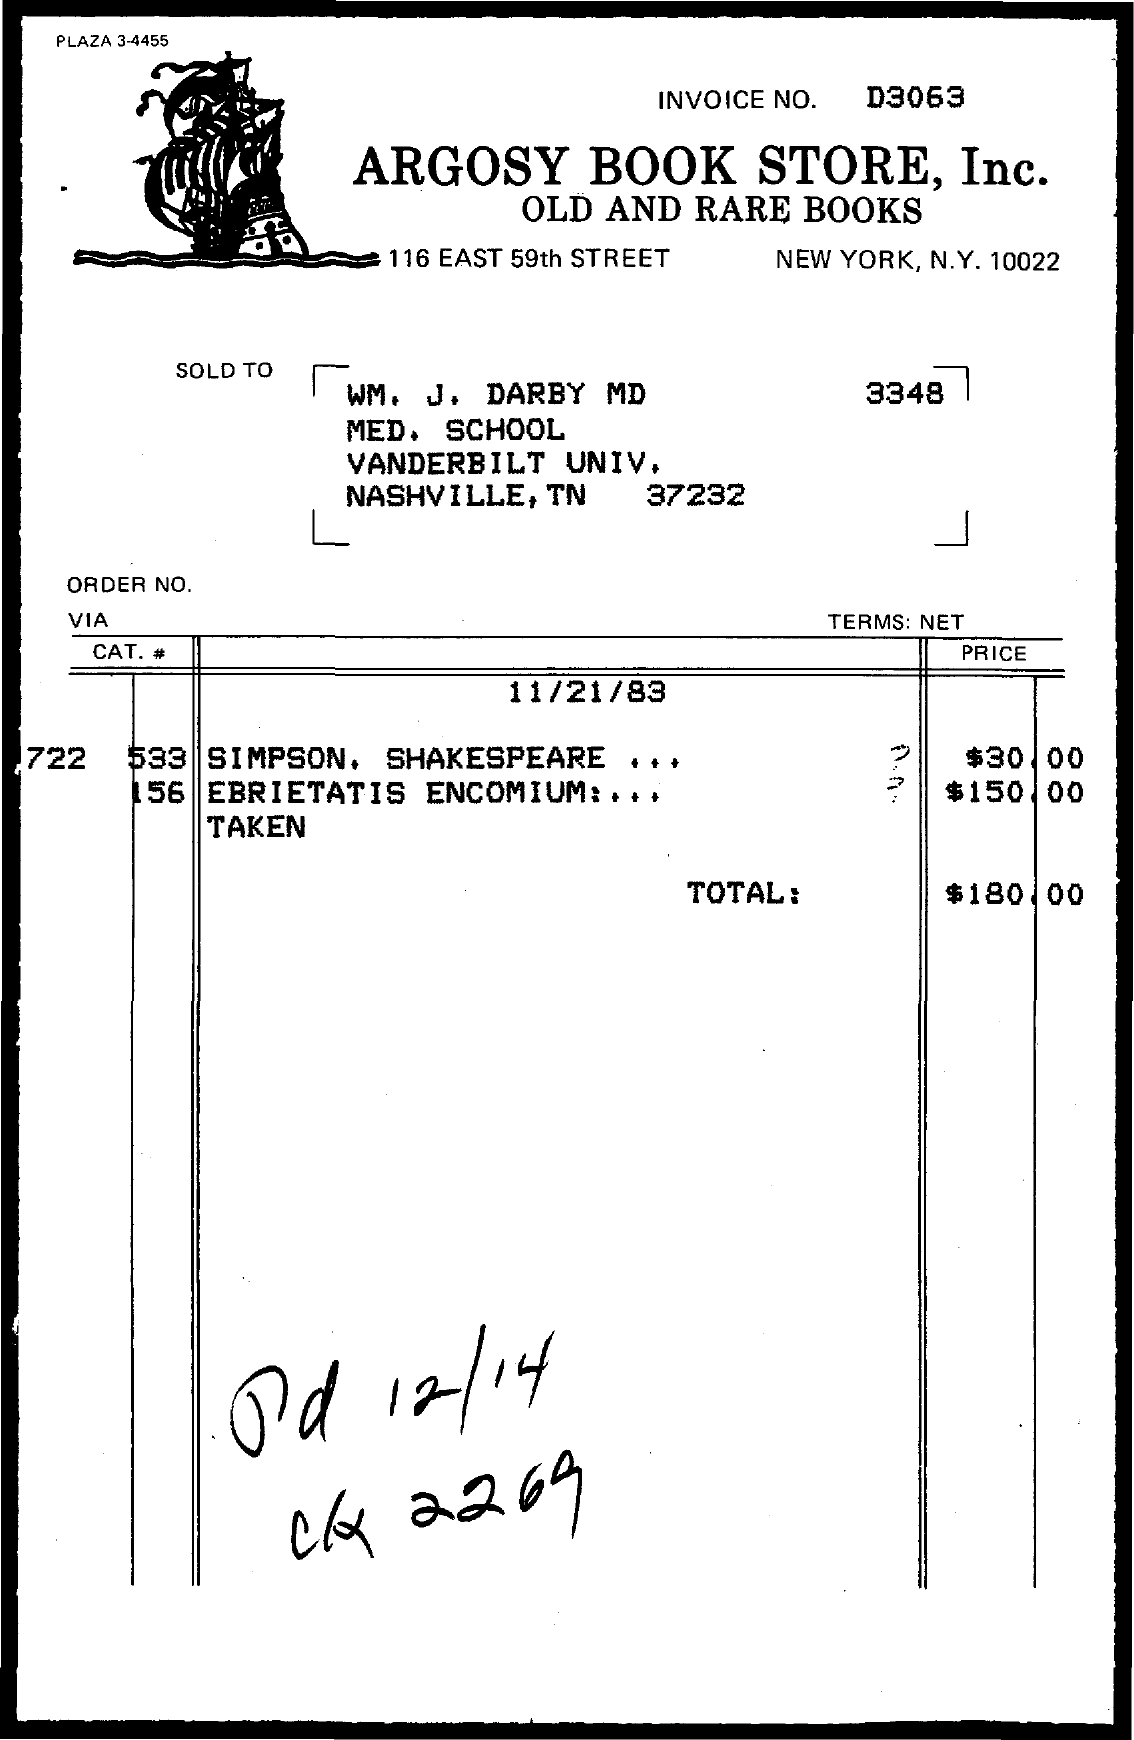Draw attention to some important aspects in this diagram. The total value in the invoice is $180.00. The invoice number is D3063. The book with the highest price listed on the invoice is EBRIETATIS ENCOMIUM... 